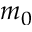<formula> <loc_0><loc_0><loc_500><loc_500>m _ { 0 }</formula> 